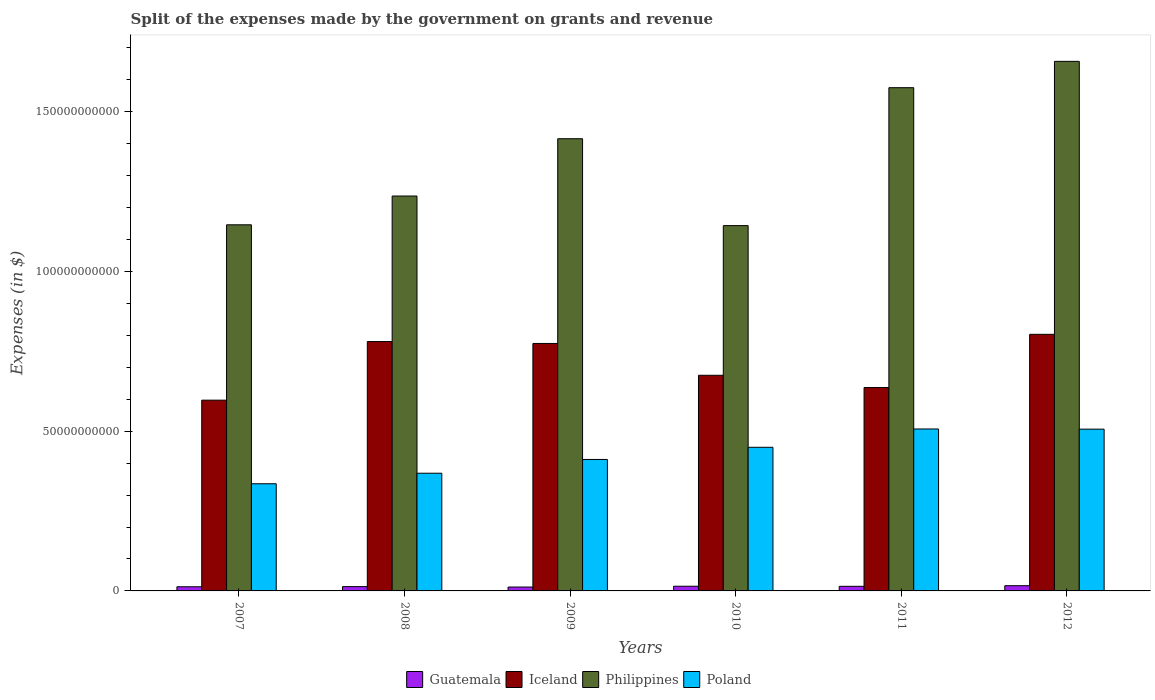How many groups of bars are there?
Provide a short and direct response. 6. Are the number of bars per tick equal to the number of legend labels?
Keep it short and to the point. Yes. How many bars are there on the 5th tick from the left?
Ensure brevity in your answer.  4. How many bars are there on the 2nd tick from the right?
Provide a short and direct response. 4. What is the label of the 2nd group of bars from the left?
Make the answer very short. 2008. What is the expenses made by the government on grants and revenue in Iceland in 2008?
Provide a short and direct response. 7.80e+1. Across all years, what is the maximum expenses made by the government on grants and revenue in Philippines?
Provide a succinct answer. 1.66e+11. Across all years, what is the minimum expenses made by the government on grants and revenue in Philippines?
Provide a succinct answer. 1.14e+11. In which year was the expenses made by the government on grants and revenue in Guatemala minimum?
Ensure brevity in your answer.  2009. What is the total expenses made by the government on grants and revenue in Philippines in the graph?
Offer a very short reply. 8.17e+11. What is the difference between the expenses made by the government on grants and revenue in Philippines in 2011 and that in 2012?
Provide a succinct answer. -8.24e+09. What is the difference between the expenses made by the government on grants and revenue in Iceland in 2009 and the expenses made by the government on grants and revenue in Guatemala in 2012?
Make the answer very short. 7.58e+1. What is the average expenses made by the government on grants and revenue in Guatemala per year?
Make the answer very short. 1.40e+09. In the year 2009, what is the difference between the expenses made by the government on grants and revenue in Philippines and expenses made by the government on grants and revenue in Iceland?
Your answer should be very brief. 6.41e+1. What is the ratio of the expenses made by the government on grants and revenue in Iceland in 2010 to that in 2011?
Provide a short and direct response. 1.06. What is the difference between the highest and the second highest expenses made by the government on grants and revenue in Philippines?
Offer a terse response. 8.24e+09. What is the difference between the highest and the lowest expenses made by the government on grants and revenue in Philippines?
Your answer should be compact. 5.14e+1. What does the 4th bar from the left in 2011 represents?
Offer a terse response. Poland. What does the 4th bar from the right in 2011 represents?
Offer a terse response. Guatemala. Is it the case that in every year, the sum of the expenses made by the government on grants and revenue in Poland and expenses made by the government on grants and revenue in Guatemala is greater than the expenses made by the government on grants and revenue in Iceland?
Keep it short and to the point. No. How many bars are there?
Keep it short and to the point. 24. Are all the bars in the graph horizontal?
Your answer should be compact. No. How many years are there in the graph?
Ensure brevity in your answer.  6. Are the values on the major ticks of Y-axis written in scientific E-notation?
Ensure brevity in your answer.  No. How many legend labels are there?
Your response must be concise. 4. What is the title of the graph?
Ensure brevity in your answer.  Split of the expenses made by the government on grants and revenue. Does "Small states" appear as one of the legend labels in the graph?
Offer a very short reply. No. What is the label or title of the Y-axis?
Offer a terse response. Expenses (in $). What is the Expenses (in $) in Guatemala in 2007?
Your answer should be compact. 1.30e+09. What is the Expenses (in $) in Iceland in 2007?
Your answer should be compact. 5.97e+1. What is the Expenses (in $) in Philippines in 2007?
Your answer should be very brief. 1.15e+11. What is the Expenses (in $) of Poland in 2007?
Offer a terse response. 3.35e+1. What is the Expenses (in $) of Guatemala in 2008?
Your answer should be compact. 1.35e+09. What is the Expenses (in $) in Iceland in 2008?
Offer a terse response. 7.80e+1. What is the Expenses (in $) in Philippines in 2008?
Provide a short and direct response. 1.24e+11. What is the Expenses (in $) of Poland in 2008?
Give a very brief answer. 3.68e+1. What is the Expenses (in $) in Guatemala in 2009?
Your answer should be compact. 1.22e+09. What is the Expenses (in $) of Iceland in 2009?
Provide a succinct answer. 7.74e+1. What is the Expenses (in $) of Philippines in 2009?
Offer a very short reply. 1.42e+11. What is the Expenses (in $) of Poland in 2009?
Your answer should be very brief. 4.11e+1. What is the Expenses (in $) of Guatemala in 2010?
Keep it short and to the point. 1.47e+09. What is the Expenses (in $) of Iceland in 2010?
Offer a terse response. 6.75e+1. What is the Expenses (in $) in Philippines in 2010?
Offer a terse response. 1.14e+11. What is the Expenses (in $) of Poland in 2010?
Keep it short and to the point. 4.49e+1. What is the Expenses (in $) of Guatemala in 2011?
Your response must be concise. 1.44e+09. What is the Expenses (in $) of Iceland in 2011?
Make the answer very short. 6.36e+1. What is the Expenses (in $) in Philippines in 2011?
Provide a succinct answer. 1.57e+11. What is the Expenses (in $) in Poland in 2011?
Offer a very short reply. 5.07e+1. What is the Expenses (in $) in Guatemala in 2012?
Offer a terse response. 1.64e+09. What is the Expenses (in $) of Iceland in 2012?
Your answer should be compact. 8.03e+1. What is the Expenses (in $) of Philippines in 2012?
Your answer should be compact. 1.66e+11. What is the Expenses (in $) in Poland in 2012?
Provide a succinct answer. 5.06e+1. Across all years, what is the maximum Expenses (in $) in Guatemala?
Make the answer very short. 1.64e+09. Across all years, what is the maximum Expenses (in $) in Iceland?
Offer a terse response. 8.03e+1. Across all years, what is the maximum Expenses (in $) of Philippines?
Your answer should be compact. 1.66e+11. Across all years, what is the maximum Expenses (in $) of Poland?
Ensure brevity in your answer.  5.07e+1. Across all years, what is the minimum Expenses (in $) in Guatemala?
Keep it short and to the point. 1.22e+09. Across all years, what is the minimum Expenses (in $) of Iceland?
Your answer should be compact. 5.97e+1. Across all years, what is the minimum Expenses (in $) in Philippines?
Your answer should be very brief. 1.14e+11. Across all years, what is the minimum Expenses (in $) of Poland?
Offer a terse response. 3.35e+1. What is the total Expenses (in $) of Guatemala in the graph?
Make the answer very short. 8.40e+09. What is the total Expenses (in $) in Iceland in the graph?
Keep it short and to the point. 4.27e+11. What is the total Expenses (in $) in Philippines in the graph?
Provide a short and direct response. 8.17e+11. What is the total Expenses (in $) of Poland in the graph?
Provide a short and direct response. 2.58e+11. What is the difference between the Expenses (in $) in Guatemala in 2007 and that in 2008?
Give a very brief answer. -4.95e+07. What is the difference between the Expenses (in $) of Iceland in 2007 and that in 2008?
Provide a succinct answer. -1.83e+1. What is the difference between the Expenses (in $) of Philippines in 2007 and that in 2008?
Ensure brevity in your answer.  -9.00e+09. What is the difference between the Expenses (in $) of Poland in 2007 and that in 2008?
Give a very brief answer. -3.30e+09. What is the difference between the Expenses (in $) in Guatemala in 2007 and that in 2009?
Your response must be concise. 8.03e+07. What is the difference between the Expenses (in $) in Iceland in 2007 and that in 2009?
Provide a short and direct response. -1.77e+1. What is the difference between the Expenses (in $) in Philippines in 2007 and that in 2009?
Ensure brevity in your answer.  -2.69e+1. What is the difference between the Expenses (in $) of Poland in 2007 and that in 2009?
Offer a very short reply. -7.61e+09. What is the difference between the Expenses (in $) in Guatemala in 2007 and that in 2010?
Make the answer very short. -1.69e+08. What is the difference between the Expenses (in $) of Iceland in 2007 and that in 2010?
Make the answer very short. -7.79e+09. What is the difference between the Expenses (in $) of Philippines in 2007 and that in 2010?
Your response must be concise. 2.58e+08. What is the difference between the Expenses (in $) of Poland in 2007 and that in 2010?
Give a very brief answer. -1.14e+1. What is the difference between the Expenses (in $) in Guatemala in 2007 and that in 2011?
Provide a succinct answer. -1.44e+08. What is the difference between the Expenses (in $) in Iceland in 2007 and that in 2011?
Your answer should be very brief. -3.95e+09. What is the difference between the Expenses (in $) in Philippines in 2007 and that in 2011?
Your answer should be very brief. -4.29e+1. What is the difference between the Expenses (in $) in Poland in 2007 and that in 2011?
Offer a very short reply. -1.71e+1. What is the difference between the Expenses (in $) of Guatemala in 2007 and that in 2012?
Offer a terse response. -3.39e+08. What is the difference between the Expenses (in $) of Iceland in 2007 and that in 2012?
Your answer should be very brief. -2.06e+1. What is the difference between the Expenses (in $) of Philippines in 2007 and that in 2012?
Give a very brief answer. -5.11e+1. What is the difference between the Expenses (in $) in Poland in 2007 and that in 2012?
Your answer should be compact. -1.71e+1. What is the difference between the Expenses (in $) in Guatemala in 2008 and that in 2009?
Provide a succinct answer. 1.30e+08. What is the difference between the Expenses (in $) in Iceland in 2008 and that in 2009?
Provide a succinct answer. 6.04e+08. What is the difference between the Expenses (in $) in Philippines in 2008 and that in 2009?
Give a very brief answer. -1.79e+1. What is the difference between the Expenses (in $) of Poland in 2008 and that in 2009?
Provide a succinct answer. -4.31e+09. What is the difference between the Expenses (in $) of Guatemala in 2008 and that in 2010?
Offer a very short reply. -1.20e+08. What is the difference between the Expenses (in $) in Iceland in 2008 and that in 2010?
Make the answer very short. 1.06e+1. What is the difference between the Expenses (in $) in Philippines in 2008 and that in 2010?
Ensure brevity in your answer.  9.26e+09. What is the difference between the Expenses (in $) of Poland in 2008 and that in 2010?
Give a very brief answer. -8.12e+09. What is the difference between the Expenses (in $) in Guatemala in 2008 and that in 2011?
Your answer should be compact. -9.49e+07. What is the difference between the Expenses (in $) in Iceland in 2008 and that in 2011?
Give a very brief answer. 1.44e+1. What is the difference between the Expenses (in $) of Philippines in 2008 and that in 2011?
Provide a succinct answer. -3.39e+1. What is the difference between the Expenses (in $) of Poland in 2008 and that in 2011?
Your answer should be very brief. -1.38e+1. What is the difference between the Expenses (in $) in Guatemala in 2008 and that in 2012?
Provide a succinct answer. -2.90e+08. What is the difference between the Expenses (in $) in Iceland in 2008 and that in 2012?
Ensure brevity in your answer.  -2.26e+09. What is the difference between the Expenses (in $) of Philippines in 2008 and that in 2012?
Offer a terse response. -4.21e+1. What is the difference between the Expenses (in $) in Poland in 2008 and that in 2012?
Make the answer very short. -1.38e+1. What is the difference between the Expenses (in $) of Guatemala in 2009 and that in 2010?
Your response must be concise. -2.49e+08. What is the difference between the Expenses (in $) of Iceland in 2009 and that in 2010?
Your response must be concise. 9.95e+09. What is the difference between the Expenses (in $) of Philippines in 2009 and that in 2010?
Give a very brief answer. 2.72e+1. What is the difference between the Expenses (in $) in Poland in 2009 and that in 2010?
Offer a terse response. -3.81e+09. What is the difference between the Expenses (in $) of Guatemala in 2009 and that in 2011?
Provide a short and direct response. -2.25e+08. What is the difference between the Expenses (in $) in Iceland in 2009 and that in 2011?
Make the answer very short. 1.38e+1. What is the difference between the Expenses (in $) of Philippines in 2009 and that in 2011?
Keep it short and to the point. -1.60e+1. What is the difference between the Expenses (in $) of Poland in 2009 and that in 2011?
Make the answer very short. -9.54e+09. What is the difference between the Expenses (in $) of Guatemala in 2009 and that in 2012?
Offer a terse response. -4.20e+08. What is the difference between the Expenses (in $) of Iceland in 2009 and that in 2012?
Ensure brevity in your answer.  -2.86e+09. What is the difference between the Expenses (in $) in Philippines in 2009 and that in 2012?
Offer a very short reply. -2.42e+1. What is the difference between the Expenses (in $) of Poland in 2009 and that in 2012?
Offer a terse response. -9.48e+09. What is the difference between the Expenses (in $) of Guatemala in 2010 and that in 2011?
Your answer should be very brief. 2.46e+07. What is the difference between the Expenses (in $) in Iceland in 2010 and that in 2011?
Offer a terse response. 3.84e+09. What is the difference between the Expenses (in $) in Philippines in 2010 and that in 2011?
Keep it short and to the point. -4.32e+1. What is the difference between the Expenses (in $) of Poland in 2010 and that in 2011?
Provide a short and direct response. -5.73e+09. What is the difference between the Expenses (in $) in Guatemala in 2010 and that in 2012?
Your answer should be very brief. -1.70e+08. What is the difference between the Expenses (in $) of Iceland in 2010 and that in 2012?
Your answer should be compact. -1.28e+1. What is the difference between the Expenses (in $) in Philippines in 2010 and that in 2012?
Your answer should be very brief. -5.14e+1. What is the difference between the Expenses (in $) of Poland in 2010 and that in 2012?
Your answer should be very brief. -5.67e+09. What is the difference between the Expenses (in $) in Guatemala in 2011 and that in 2012?
Offer a terse response. -1.95e+08. What is the difference between the Expenses (in $) in Iceland in 2011 and that in 2012?
Make the answer very short. -1.67e+1. What is the difference between the Expenses (in $) of Philippines in 2011 and that in 2012?
Ensure brevity in your answer.  -8.24e+09. What is the difference between the Expenses (in $) of Poland in 2011 and that in 2012?
Provide a short and direct response. 5.60e+07. What is the difference between the Expenses (in $) of Guatemala in 2007 and the Expenses (in $) of Iceland in 2008?
Give a very brief answer. -7.67e+1. What is the difference between the Expenses (in $) in Guatemala in 2007 and the Expenses (in $) in Philippines in 2008?
Provide a succinct answer. -1.22e+11. What is the difference between the Expenses (in $) of Guatemala in 2007 and the Expenses (in $) of Poland in 2008?
Keep it short and to the point. -3.55e+1. What is the difference between the Expenses (in $) in Iceland in 2007 and the Expenses (in $) in Philippines in 2008?
Your answer should be very brief. -6.39e+1. What is the difference between the Expenses (in $) of Iceland in 2007 and the Expenses (in $) of Poland in 2008?
Provide a succinct answer. 2.29e+1. What is the difference between the Expenses (in $) in Philippines in 2007 and the Expenses (in $) in Poland in 2008?
Provide a short and direct response. 7.77e+1. What is the difference between the Expenses (in $) in Guatemala in 2007 and the Expenses (in $) in Iceland in 2009?
Give a very brief answer. -7.61e+1. What is the difference between the Expenses (in $) of Guatemala in 2007 and the Expenses (in $) of Philippines in 2009?
Your response must be concise. -1.40e+11. What is the difference between the Expenses (in $) of Guatemala in 2007 and the Expenses (in $) of Poland in 2009?
Provide a short and direct response. -3.98e+1. What is the difference between the Expenses (in $) in Iceland in 2007 and the Expenses (in $) in Philippines in 2009?
Ensure brevity in your answer.  -8.18e+1. What is the difference between the Expenses (in $) in Iceland in 2007 and the Expenses (in $) in Poland in 2009?
Give a very brief answer. 1.86e+1. What is the difference between the Expenses (in $) of Philippines in 2007 and the Expenses (in $) of Poland in 2009?
Your answer should be very brief. 7.34e+1. What is the difference between the Expenses (in $) in Guatemala in 2007 and the Expenses (in $) in Iceland in 2010?
Keep it short and to the point. -6.62e+1. What is the difference between the Expenses (in $) of Guatemala in 2007 and the Expenses (in $) of Philippines in 2010?
Keep it short and to the point. -1.13e+11. What is the difference between the Expenses (in $) in Guatemala in 2007 and the Expenses (in $) in Poland in 2010?
Make the answer very short. -4.37e+1. What is the difference between the Expenses (in $) of Iceland in 2007 and the Expenses (in $) of Philippines in 2010?
Your answer should be compact. -5.46e+1. What is the difference between the Expenses (in $) of Iceland in 2007 and the Expenses (in $) of Poland in 2010?
Give a very brief answer. 1.47e+1. What is the difference between the Expenses (in $) in Philippines in 2007 and the Expenses (in $) in Poland in 2010?
Provide a succinct answer. 6.96e+1. What is the difference between the Expenses (in $) of Guatemala in 2007 and the Expenses (in $) of Iceland in 2011?
Make the answer very short. -6.23e+1. What is the difference between the Expenses (in $) of Guatemala in 2007 and the Expenses (in $) of Philippines in 2011?
Offer a very short reply. -1.56e+11. What is the difference between the Expenses (in $) of Guatemala in 2007 and the Expenses (in $) of Poland in 2011?
Your answer should be compact. -4.94e+1. What is the difference between the Expenses (in $) in Iceland in 2007 and the Expenses (in $) in Philippines in 2011?
Offer a very short reply. -9.78e+1. What is the difference between the Expenses (in $) of Iceland in 2007 and the Expenses (in $) of Poland in 2011?
Make the answer very short. 9.02e+09. What is the difference between the Expenses (in $) of Philippines in 2007 and the Expenses (in $) of Poland in 2011?
Make the answer very short. 6.39e+1. What is the difference between the Expenses (in $) of Guatemala in 2007 and the Expenses (in $) of Iceland in 2012?
Your answer should be very brief. -7.90e+1. What is the difference between the Expenses (in $) in Guatemala in 2007 and the Expenses (in $) in Philippines in 2012?
Keep it short and to the point. -1.64e+11. What is the difference between the Expenses (in $) in Guatemala in 2007 and the Expenses (in $) in Poland in 2012?
Give a very brief answer. -4.93e+1. What is the difference between the Expenses (in $) of Iceland in 2007 and the Expenses (in $) of Philippines in 2012?
Make the answer very short. -1.06e+11. What is the difference between the Expenses (in $) of Iceland in 2007 and the Expenses (in $) of Poland in 2012?
Give a very brief answer. 9.07e+09. What is the difference between the Expenses (in $) of Philippines in 2007 and the Expenses (in $) of Poland in 2012?
Keep it short and to the point. 6.39e+1. What is the difference between the Expenses (in $) of Guatemala in 2008 and the Expenses (in $) of Iceland in 2009?
Give a very brief answer. -7.61e+1. What is the difference between the Expenses (in $) of Guatemala in 2008 and the Expenses (in $) of Philippines in 2009?
Make the answer very short. -1.40e+11. What is the difference between the Expenses (in $) of Guatemala in 2008 and the Expenses (in $) of Poland in 2009?
Provide a succinct answer. -3.98e+1. What is the difference between the Expenses (in $) in Iceland in 2008 and the Expenses (in $) in Philippines in 2009?
Your answer should be compact. -6.35e+1. What is the difference between the Expenses (in $) of Iceland in 2008 and the Expenses (in $) of Poland in 2009?
Offer a very short reply. 3.69e+1. What is the difference between the Expenses (in $) in Philippines in 2008 and the Expenses (in $) in Poland in 2009?
Offer a terse response. 8.24e+1. What is the difference between the Expenses (in $) in Guatemala in 2008 and the Expenses (in $) in Iceland in 2010?
Your answer should be compact. -6.61e+1. What is the difference between the Expenses (in $) of Guatemala in 2008 and the Expenses (in $) of Philippines in 2010?
Offer a terse response. -1.13e+11. What is the difference between the Expenses (in $) in Guatemala in 2008 and the Expenses (in $) in Poland in 2010?
Ensure brevity in your answer.  -4.36e+1. What is the difference between the Expenses (in $) of Iceland in 2008 and the Expenses (in $) of Philippines in 2010?
Make the answer very short. -3.63e+1. What is the difference between the Expenses (in $) in Iceland in 2008 and the Expenses (in $) in Poland in 2010?
Provide a succinct answer. 3.31e+1. What is the difference between the Expenses (in $) of Philippines in 2008 and the Expenses (in $) of Poland in 2010?
Offer a terse response. 7.86e+1. What is the difference between the Expenses (in $) in Guatemala in 2008 and the Expenses (in $) in Iceland in 2011?
Provide a short and direct response. -6.23e+1. What is the difference between the Expenses (in $) in Guatemala in 2008 and the Expenses (in $) in Philippines in 2011?
Keep it short and to the point. -1.56e+11. What is the difference between the Expenses (in $) of Guatemala in 2008 and the Expenses (in $) of Poland in 2011?
Provide a succinct answer. -4.93e+1. What is the difference between the Expenses (in $) of Iceland in 2008 and the Expenses (in $) of Philippines in 2011?
Offer a terse response. -7.94e+1. What is the difference between the Expenses (in $) of Iceland in 2008 and the Expenses (in $) of Poland in 2011?
Your answer should be very brief. 2.74e+1. What is the difference between the Expenses (in $) of Philippines in 2008 and the Expenses (in $) of Poland in 2011?
Your answer should be very brief. 7.29e+1. What is the difference between the Expenses (in $) of Guatemala in 2008 and the Expenses (in $) of Iceland in 2012?
Your response must be concise. -7.89e+1. What is the difference between the Expenses (in $) in Guatemala in 2008 and the Expenses (in $) in Philippines in 2012?
Your response must be concise. -1.64e+11. What is the difference between the Expenses (in $) in Guatemala in 2008 and the Expenses (in $) in Poland in 2012?
Your response must be concise. -4.93e+1. What is the difference between the Expenses (in $) in Iceland in 2008 and the Expenses (in $) in Philippines in 2012?
Make the answer very short. -8.77e+1. What is the difference between the Expenses (in $) in Iceland in 2008 and the Expenses (in $) in Poland in 2012?
Your answer should be very brief. 2.74e+1. What is the difference between the Expenses (in $) of Philippines in 2008 and the Expenses (in $) of Poland in 2012?
Offer a very short reply. 7.29e+1. What is the difference between the Expenses (in $) in Guatemala in 2009 and the Expenses (in $) in Iceland in 2010?
Your response must be concise. -6.63e+1. What is the difference between the Expenses (in $) of Guatemala in 2009 and the Expenses (in $) of Philippines in 2010?
Offer a terse response. -1.13e+11. What is the difference between the Expenses (in $) of Guatemala in 2009 and the Expenses (in $) of Poland in 2010?
Offer a very short reply. -4.37e+1. What is the difference between the Expenses (in $) of Iceland in 2009 and the Expenses (in $) of Philippines in 2010?
Provide a short and direct response. -3.69e+1. What is the difference between the Expenses (in $) in Iceland in 2009 and the Expenses (in $) in Poland in 2010?
Give a very brief answer. 3.25e+1. What is the difference between the Expenses (in $) in Philippines in 2009 and the Expenses (in $) in Poland in 2010?
Make the answer very short. 9.66e+1. What is the difference between the Expenses (in $) of Guatemala in 2009 and the Expenses (in $) of Iceland in 2011?
Provide a short and direct response. -6.24e+1. What is the difference between the Expenses (in $) in Guatemala in 2009 and the Expenses (in $) in Philippines in 2011?
Provide a short and direct response. -1.56e+11. What is the difference between the Expenses (in $) of Guatemala in 2009 and the Expenses (in $) of Poland in 2011?
Provide a short and direct response. -4.95e+1. What is the difference between the Expenses (in $) of Iceland in 2009 and the Expenses (in $) of Philippines in 2011?
Your response must be concise. -8.00e+1. What is the difference between the Expenses (in $) in Iceland in 2009 and the Expenses (in $) in Poland in 2011?
Your answer should be very brief. 2.68e+1. What is the difference between the Expenses (in $) in Philippines in 2009 and the Expenses (in $) in Poland in 2011?
Keep it short and to the point. 9.08e+1. What is the difference between the Expenses (in $) of Guatemala in 2009 and the Expenses (in $) of Iceland in 2012?
Provide a succinct answer. -7.91e+1. What is the difference between the Expenses (in $) of Guatemala in 2009 and the Expenses (in $) of Philippines in 2012?
Make the answer very short. -1.64e+11. What is the difference between the Expenses (in $) in Guatemala in 2009 and the Expenses (in $) in Poland in 2012?
Offer a terse response. -4.94e+1. What is the difference between the Expenses (in $) of Iceland in 2009 and the Expenses (in $) of Philippines in 2012?
Provide a short and direct response. -8.83e+1. What is the difference between the Expenses (in $) in Iceland in 2009 and the Expenses (in $) in Poland in 2012?
Provide a short and direct response. 2.68e+1. What is the difference between the Expenses (in $) of Philippines in 2009 and the Expenses (in $) of Poland in 2012?
Keep it short and to the point. 9.09e+1. What is the difference between the Expenses (in $) in Guatemala in 2010 and the Expenses (in $) in Iceland in 2011?
Give a very brief answer. -6.22e+1. What is the difference between the Expenses (in $) in Guatemala in 2010 and the Expenses (in $) in Philippines in 2011?
Offer a very short reply. -1.56e+11. What is the difference between the Expenses (in $) in Guatemala in 2010 and the Expenses (in $) in Poland in 2011?
Your response must be concise. -4.92e+1. What is the difference between the Expenses (in $) in Iceland in 2010 and the Expenses (in $) in Philippines in 2011?
Offer a very short reply. -9.00e+1. What is the difference between the Expenses (in $) in Iceland in 2010 and the Expenses (in $) in Poland in 2011?
Offer a very short reply. 1.68e+1. What is the difference between the Expenses (in $) of Philippines in 2010 and the Expenses (in $) of Poland in 2011?
Offer a very short reply. 6.36e+1. What is the difference between the Expenses (in $) in Guatemala in 2010 and the Expenses (in $) in Iceland in 2012?
Offer a very short reply. -7.88e+1. What is the difference between the Expenses (in $) of Guatemala in 2010 and the Expenses (in $) of Philippines in 2012?
Provide a short and direct response. -1.64e+11. What is the difference between the Expenses (in $) in Guatemala in 2010 and the Expenses (in $) in Poland in 2012?
Give a very brief answer. -4.92e+1. What is the difference between the Expenses (in $) in Iceland in 2010 and the Expenses (in $) in Philippines in 2012?
Your answer should be very brief. -9.82e+1. What is the difference between the Expenses (in $) in Iceland in 2010 and the Expenses (in $) in Poland in 2012?
Give a very brief answer. 1.69e+1. What is the difference between the Expenses (in $) of Philippines in 2010 and the Expenses (in $) of Poland in 2012?
Ensure brevity in your answer.  6.37e+1. What is the difference between the Expenses (in $) in Guatemala in 2011 and the Expenses (in $) in Iceland in 2012?
Keep it short and to the point. -7.89e+1. What is the difference between the Expenses (in $) of Guatemala in 2011 and the Expenses (in $) of Philippines in 2012?
Keep it short and to the point. -1.64e+11. What is the difference between the Expenses (in $) in Guatemala in 2011 and the Expenses (in $) in Poland in 2012?
Offer a very short reply. -4.92e+1. What is the difference between the Expenses (in $) in Iceland in 2011 and the Expenses (in $) in Philippines in 2012?
Provide a succinct answer. -1.02e+11. What is the difference between the Expenses (in $) in Iceland in 2011 and the Expenses (in $) in Poland in 2012?
Your answer should be very brief. 1.30e+1. What is the difference between the Expenses (in $) in Philippines in 2011 and the Expenses (in $) in Poland in 2012?
Ensure brevity in your answer.  1.07e+11. What is the average Expenses (in $) of Guatemala per year?
Your answer should be compact. 1.40e+09. What is the average Expenses (in $) in Iceland per year?
Your answer should be compact. 7.11e+1. What is the average Expenses (in $) of Philippines per year?
Provide a short and direct response. 1.36e+11. What is the average Expenses (in $) in Poland per year?
Offer a very short reply. 4.30e+1. In the year 2007, what is the difference between the Expenses (in $) of Guatemala and Expenses (in $) of Iceland?
Keep it short and to the point. -5.84e+1. In the year 2007, what is the difference between the Expenses (in $) in Guatemala and Expenses (in $) in Philippines?
Your response must be concise. -1.13e+11. In the year 2007, what is the difference between the Expenses (in $) in Guatemala and Expenses (in $) in Poland?
Give a very brief answer. -3.22e+1. In the year 2007, what is the difference between the Expenses (in $) of Iceland and Expenses (in $) of Philippines?
Provide a succinct answer. -5.49e+1. In the year 2007, what is the difference between the Expenses (in $) in Iceland and Expenses (in $) in Poland?
Offer a terse response. 2.62e+1. In the year 2007, what is the difference between the Expenses (in $) of Philippines and Expenses (in $) of Poland?
Provide a short and direct response. 8.10e+1. In the year 2008, what is the difference between the Expenses (in $) in Guatemala and Expenses (in $) in Iceland?
Offer a terse response. -7.67e+1. In the year 2008, what is the difference between the Expenses (in $) in Guatemala and Expenses (in $) in Philippines?
Keep it short and to the point. -1.22e+11. In the year 2008, what is the difference between the Expenses (in $) of Guatemala and Expenses (in $) of Poland?
Ensure brevity in your answer.  -3.55e+1. In the year 2008, what is the difference between the Expenses (in $) in Iceland and Expenses (in $) in Philippines?
Your response must be concise. -4.55e+1. In the year 2008, what is the difference between the Expenses (in $) of Iceland and Expenses (in $) of Poland?
Your answer should be very brief. 4.12e+1. In the year 2008, what is the difference between the Expenses (in $) in Philippines and Expenses (in $) in Poland?
Your answer should be compact. 8.67e+1. In the year 2009, what is the difference between the Expenses (in $) of Guatemala and Expenses (in $) of Iceland?
Give a very brief answer. -7.62e+1. In the year 2009, what is the difference between the Expenses (in $) of Guatemala and Expenses (in $) of Philippines?
Keep it short and to the point. -1.40e+11. In the year 2009, what is the difference between the Expenses (in $) in Guatemala and Expenses (in $) in Poland?
Ensure brevity in your answer.  -3.99e+1. In the year 2009, what is the difference between the Expenses (in $) in Iceland and Expenses (in $) in Philippines?
Provide a short and direct response. -6.41e+1. In the year 2009, what is the difference between the Expenses (in $) of Iceland and Expenses (in $) of Poland?
Your response must be concise. 3.63e+1. In the year 2009, what is the difference between the Expenses (in $) in Philippines and Expenses (in $) in Poland?
Provide a succinct answer. 1.00e+11. In the year 2010, what is the difference between the Expenses (in $) of Guatemala and Expenses (in $) of Iceland?
Keep it short and to the point. -6.60e+1. In the year 2010, what is the difference between the Expenses (in $) in Guatemala and Expenses (in $) in Philippines?
Offer a terse response. -1.13e+11. In the year 2010, what is the difference between the Expenses (in $) of Guatemala and Expenses (in $) of Poland?
Provide a succinct answer. -4.35e+1. In the year 2010, what is the difference between the Expenses (in $) of Iceland and Expenses (in $) of Philippines?
Offer a very short reply. -4.68e+1. In the year 2010, what is the difference between the Expenses (in $) of Iceland and Expenses (in $) of Poland?
Ensure brevity in your answer.  2.25e+1. In the year 2010, what is the difference between the Expenses (in $) in Philippines and Expenses (in $) in Poland?
Keep it short and to the point. 6.94e+1. In the year 2011, what is the difference between the Expenses (in $) of Guatemala and Expenses (in $) of Iceland?
Offer a very short reply. -6.22e+1. In the year 2011, what is the difference between the Expenses (in $) in Guatemala and Expenses (in $) in Philippines?
Offer a very short reply. -1.56e+11. In the year 2011, what is the difference between the Expenses (in $) of Guatemala and Expenses (in $) of Poland?
Offer a terse response. -4.92e+1. In the year 2011, what is the difference between the Expenses (in $) in Iceland and Expenses (in $) in Philippines?
Offer a terse response. -9.38e+1. In the year 2011, what is the difference between the Expenses (in $) in Iceland and Expenses (in $) in Poland?
Your response must be concise. 1.30e+1. In the year 2011, what is the difference between the Expenses (in $) in Philippines and Expenses (in $) in Poland?
Provide a succinct answer. 1.07e+11. In the year 2012, what is the difference between the Expenses (in $) of Guatemala and Expenses (in $) of Iceland?
Offer a very short reply. -7.87e+1. In the year 2012, what is the difference between the Expenses (in $) in Guatemala and Expenses (in $) in Philippines?
Offer a very short reply. -1.64e+11. In the year 2012, what is the difference between the Expenses (in $) of Guatemala and Expenses (in $) of Poland?
Your answer should be compact. -4.90e+1. In the year 2012, what is the difference between the Expenses (in $) of Iceland and Expenses (in $) of Philippines?
Keep it short and to the point. -8.54e+1. In the year 2012, what is the difference between the Expenses (in $) in Iceland and Expenses (in $) in Poland?
Your answer should be compact. 2.97e+1. In the year 2012, what is the difference between the Expenses (in $) in Philippines and Expenses (in $) in Poland?
Give a very brief answer. 1.15e+11. What is the ratio of the Expenses (in $) of Guatemala in 2007 to that in 2008?
Your response must be concise. 0.96. What is the ratio of the Expenses (in $) of Iceland in 2007 to that in 2008?
Your response must be concise. 0.76. What is the ratio of the Expenses (in $) of Philippines in 2007 to that in 2008?
Keep it short and to the point. 0.93. What is the ratio of the Expenses (in $) in Poland in 2007 to that in 2008?
Offer a terse response. 0.91. What is the ratio of the Expenses (in $) of Guatemala in 2007 to that in 2009?
Give a very brief answer. 1.07. What is the ratio of the Expenses (in $) in Iceland in 2007 to that in 2009?
Make the answer very short. 0.77. What is the ratio of the Expenses (in $) in Philippines in 2007 to that in 2009?
Make the answer very short. 0.81. What is the ratio of the Expenses (in $) of Poland in 2007 to that in 2009?
Give a very brief answer. 0.82. What is the ratio of the Expenses (in $) in Guatemala in 2007 to that in 2010?
Make the answer very short. 0.88. What is the ratio of the Expenses (in $) of Iceland in 2007 to that in 2010?
Ensure brevity in your answer.  0.88. What is the ratio of the Expenses (in $) of Philippines in 2007 to that in 2010?
Give a very brief answer. 1. What is the ratio of the Expenses (in $) in Poland in 2007 to that in 2010?
Offer a terse response. 0.75. What is the ratio of the Expenses (in $) in Guatemala in 2007 to that in 2011?
Offer a terse response. 0.9. What is the ratio of the Expenses (in $) of Iceland in 2007 to that in 2011?
Offer a very short reply. 0.94. What is the ratio of the Expenses (in $) of Philippines in 2007 to that in 2011?
Offer a terse response. 0.73. What is the ratio of the Expenses (in $) in Poland in 2007 to that in 2011?
Give a very brief answer. 0.66. What is the ratio of the Expenses (in $) in Guatemala in 2007 to that in 2012?
Keep it short and to the point. 0.79. What is the ratio of the Expenses (in $) of Iceland in 2007 to that in 2012?
Make the answer very short. 0.74. What is the ratio of the Expenses (in $) in Philippines in 2007 to that in 2012?
Keep it short and to the point. 0.69. What is the ratio of the Expenses (in $) in Poland in 2007 to that in 2012?
Your answer should be very brief. 0.66. What is the ratio of the Expenses (in $) in Guatemala in 2008 to that in 2009?
Ensure brevity in your answer.  1.11. What is the ratio of the Expenses (in $) in Philippines in 2008 to that in 2009?
Your response must be concise. 0.87. What is the ratio of the Expenses (in $) in Poland in 2008 to that in 2009?
Provide a succinct answer. 0.9. What is the ratio of the Expenses (in $) of Guatemala in 2008 to that in 2010?
Offer a very short reply. 0.92. What is the ratio of the Expenses (in $) in Iceland in 2008 to that in 2010?
Provide a short and direct response. 1.16. What is the ratio of the Expenses (in $) of Philippines in 2008 to that in 2010?
Provide a succinct answer. 1.08. What is the ratio of the Expenses (in $) in Poland in 2008 to that in 2010?
Your response must be concise. 0.82. What is the ratio of the Expenses (in $) in Guatemala in 2008 to that in 2011?
Make the answer very short. 0.93. What is the ratio of the Expenses (in $) in Iceland in 2008 to that in 2011?
Your answer should be very brief. 1.23. What is the ratio of the Expenses (in $) of Philippines in 2008 to that in 2011?
Ensure brevity in your answer.  0.78. What is the ratio of the Expenses (in $) in Poland in 2008 to that in 2011?
Keep it short and to the point. 0.73. What is the ratio of the Expenses (in $) of Guatemala in 2008 to that in 2012?
Your response must be concise. 0.82. What is the ratio of the Expenses (in $) of Iceland in 2008 to that in 2012?
Provide a succinct answer. 0.97. What is the ratio of the Expenses (in $) of Philippines in 2008 to that in 2012?
Your answer should be compact. 0.75. What is the ratio of the Expenses (in $) in Poland in 2008 to that in 2012?
Make the answer very short. 0.73. What is the ratio of the Expenses (in $) of Guatemala in 2009 to that in 2010?
Your response must be concise. 0.83. What is the ratio of the Expenses (in $) in Iceland in 2009 to that in 2010?
Offer a very short reply. 1.15. What is the ratio of the Expenses (in $) in Philippines in 2009 to that in 2010?
Make the answer very short. 1.24. What is the ratio of the Expenses (in $) in Poland in 2009 to that in 2010?
Make the answer very short. 0.92. What is the ratio of the Expenses (in $) in Guatemala in 2009 to that in 2011?
Keep it short and to the point. 0.84. What is the ratio of the Expenses (in $) of Iceland in 2009 to that in 2011?
Your answer should be very brief. 1.22. What is the ratio of the Expenses (in $) in Philippines in 2009 to that in 2011?
Your answer should be compact. 0.9. What is the ratio of the Expenses (in $) in Poland in 2009 to that in 2011?
Ensure brevity in your answer.  0.81. What is the ratio of the Expenses (in $) in Guatemala in 2009 to that in 2012?
Offer a very short reply. 0.74. What is the ratio of the Expenses (in $) in Iceland in 2009 to that in 2012?
Your answer should be very brief. 0.96. What is the ratio of the Expenses (in $) of Philippines in 2009 to that in 2012?
Provide a short and direct response. 0.85. What is the ratio of the Expenses (in $) of Poland in 2009 to that in 2012?
Ensure brevity in your answer.  0.81. What is the ratio of the Expenses (in $) in Guatemala in 2010 to that in 2011?
Offer a very short reply. 1.02. What is the ratio of the Expenses (in $) of Iceland in 2010 to that in 2011?
Provide a succinct answer. 1.06. What is the ratio of the Expenses (in $) of Philippines in 2010 to that in 2011?
Ensure brevity in your answer.  0.73. What is the ratio of the Expenses (in $) in Poland in 2010 to that in 2011?
Your response must be concise. 0.89. What is the ratio of the Expenses (in $) in Guatemala in 2010 to that in 2012?
Offer a very short reply. 0.9. What is the ratio of the Expenses (in $) in Iceland in 2010 to that in 2012?
Ensure brevity in your answer.  0.84. What is the ratio of the Expenses (in $) of Philippines in 2010 to that in 2012?
Your response must be concise. 0.69. What is the ratio of the Expenses (in $) of Poland in 2010 to that in 2012?
Offer a very short reply. 0.89. What is the ratio of the Expenses (in $) of Guatemala in 2011 to that in 2012?
Provide a short and direct response. 0.88. What is the ratio of the Expenses (in $) of Iceland in 2011 to that in 2012?
Ensure brevity in your answer.  0.79. What is the ratio of the Expenses (in $) in Philippines in 2011 to that in 2012?
Keep it short and to the point. 0.95. What is the difference between the highest and the second highest Expenses (in $) of Guatemala?
Offer a very short reply. 1.70e+08. What is the difference between the highest and the second highest Expenses (in $) of Iceland?
Ensure brevity in your answer.  2.26e+09. What is the difference between the highest and the second highest Expenses (in $) of Philippines?
Your answer should be compact. 8.24e+09. What is the difference between the highest and the second highest Expenses (in $) of Poland?
Your response must be concise. 5.60e+07. What is the difference between the highest and the lowest Expenses (in $) in Guatemala?
Give a very brief answer. 4.20e+08. What is the difference between the highest and the lowest Expenses (in $) of Iceland?
Keep it short and to the point. 2.06e+1. What is the difference between the highest and the lowest Expenses (in $) of Philippines?
Your response must be concise. 5.14e+1. What is the difference between the highest and the lowest Expenses (in $) of Poland?
Keep it short and to the point. 1.71e+1. 